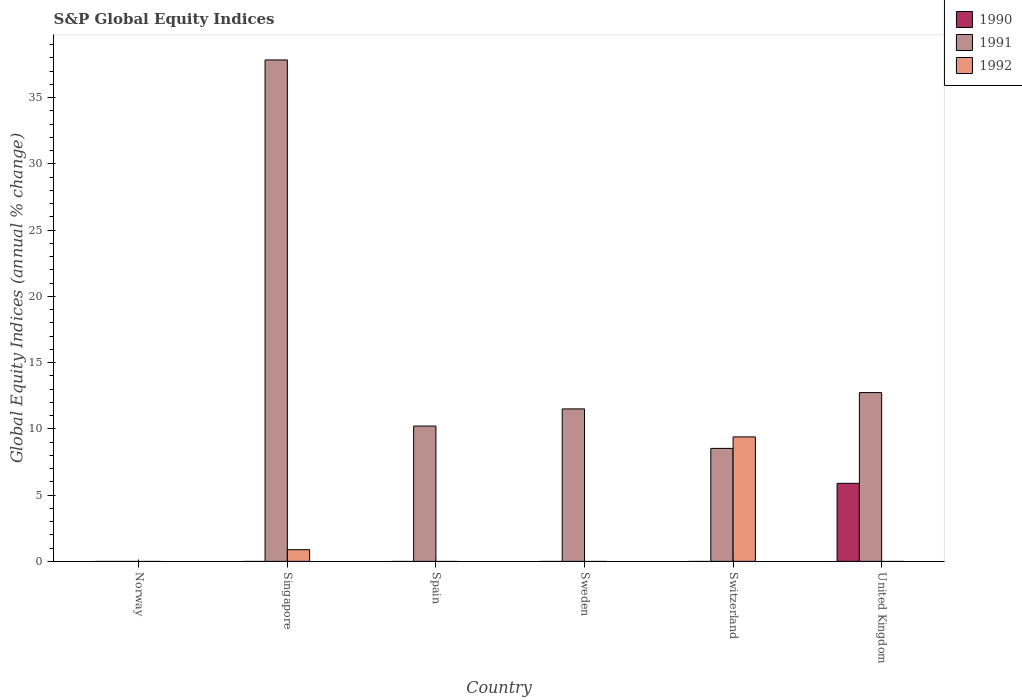Are the number of bars per tick equal to the number of legend labels?
Ensure brevity in your answer.  No. Are the number of bars on each tick of the X-axis equal?
Offer a terse response. No. How many bars are there on the 5th tick from the left?
Keep it short and to the point. 2. How many bars are there on the 3rd tick from the right?
Give a very brief answer. 1. What is the global equity indices in 1992 in Switzerland?
Keep it short and to the point. 9.4. Across all countries, what is the maximum global equity indices in 1991?
Your answer should be compact. 37.85. Across all countries, what is the minimum global equity indices in 1991?
Provide a succinct answer. 0. In which country was the global equity indices in 1992 maximum?
Provide a succinct answer. Switzerland. What is the total global equity indices in 1991 in the graph?
Ensure brevity in your answer.  80.84. What is the difference between the global equity indices in 1991 in Singapore and that in Spain?
Your answer should be compact. 27.64. What is the difference between the global equity indices in 1992 in Sweden and the global equity indices in 1991 in Singapore?
Give a very brief answer. -37.85. What is the average global equity indices in 1990 per country?
Provide a short and direct response. 0.98. What is the difference between the global equity indices of/in 1990 and global equity indices of/in 1991 in United Kingdom?
Provide a short and direct response. -6.85. In how many countries, is the global equity indices in 1991 greater than 17 %?
Provide a short and direct response. 1. What is the ratio of the global equity indices in 1991 in Sweden to that in United Kingdom?
Give a very brief answer. 0.9. What is the difference between the highest and the second highest global equity indices in 1991?
Ensure brevity in your answer.  -1.23. What is the difference between the highest and the lowest global equity indices in 1990?
Keep it short and to the point. 5.89. How many bars are there?
Provide a short and direct response. 8. Does the graph contain any zero values?
Keep it short and to the point. Yes. How many legend labels are there?
Make the answer very short. 3. How are the legend labels stacked?
Make the answer very short. Vertical. What is the title of the graph?
Ensure brevity in your answer.  S&P Global Equity Indices. Does "2008" appear as one of the legend labels in the graph?
Keep it short and to the point. No. What is the label or title of the Y-axis?
Provide a succinct answer. Global Equity Indices (annual % change). What is the Global Equity Indices (annual % change) in 1990 in Norway?
Offer a very short reply. 0. What is the Global Equity Indices (annual % change) in 1991 in Singapore?
Ensure brevity in your answer.  37.85. What is the Global Equity Indices (annual % change) in 1992 in Singapore?
Give a very brief answer. 0.88. What is the Global Equity Indices (annual % change) in 1990 in Spain?
Keep it short and to the point. 0. What is the Global Equity Indices (annual % change) of 1991 in Spain?
Your response must be concise. 10.21. What is the Global Equity Indices (annual % change) of 1990 in Sweden?
Make the answer very short. 0. What is the Global Equity Indices (annual % change) in 1991 in Sweden?
Your answer should be compact. 11.51. What is the Global Equity Indices (annual % change) in 1992 in Sweden?
Offer a very short reply. 0. What is the Global Equity Indices (annual % change) in 1991 in Switzerland?
Offer a very short reply. 8.53. What is the Global Equity Indices (annual % change) in 1992 in Switzerland?
Ensure brevity in your answer.  9.4. What is the Global Equity Indices (annual % change) of 1990 in United Kingdom?
Offer a very short reply. 5.89. What is the Global Equity Indices (annual % change) in 1991 in United Kingdom?
Offer a very short reply. 12.74. Across all countries, what is the maximum Global Equity Indices (annual % change) of 1990?
Keep it short and to the point. 5.89. Across all countries, what is the maximum Global Equity Indices (annual % change) of 1991?
Your answer should be very brief. 37.85. Across all countries, what is the maximum Global Equity Indices (annual % change) in 1992?
Provide a short and direct response. 9.4. Across all countries, what is the minimum Global Equity Indices (annual % change) in 1991?
Offer a terse response. 0. What is the total Global Equity Indices (annual % change) of 1990 in the graph?
Your response must be concise. 5.89. What is the total Global Equity Indices (annual % change) of 1991 in the graph?
Provide a short and direct response. 80.84. What is the total Global Equity Indices (annual % change) of 1992 in the graph?
Provide a short and direct response. 10.28. What is the difference between the Global Equity Indices (annual % change) of 1991 in Singapore and that in Spain?
Offer a very short reply. 27.64. What is the difference between the Global Equity Indices (annual % change) in 1991 in Singapore and that in Sweden?
Make the answer very short. 26.34. What is the difference between the Global Equity Indices (annual % change) of 1991 in Singapore and that in Switzerland?
Offer a very short reply. 29.32. What is the difference between the Global Equity Indices (annual % change) in 1992 in Singapore and that in Switzerland?
Ensure brevity in your answer.  -8.51. What is the difference between the Global Equity Indices (annual % change) of 1991 in Singapore and that in United Kingdom?
Offer a very short reply. 25.11. What is the difference between the Global Equity Indices (annual % change) of 1991 in Spain and that in Sweden?
Keep it short and to the point. -1.29. What is the difference between the Global Equity Indices (annual % change) of 1991 in Spain and that in Switzerland?
Your answer should be compact. 1.69. What is the difference between the Global Equity Indices (annual % change) of 1991 in Spain and that in United Kingdom?
Your answer should be compact. -2.53. What is the difference between the Global Equity Indices (annual % change) in 1991 in Sweden and that in Switzerland?
Ensure brevity in your answer.  2.98. What is the difference between the Global Equity Indices (annual % change) of 1991 in Sweden and that in United Kingdom?
Keep it short and to the point. -1.23. What is the difference between the Global Equity Indices (annual % change) of 1991 in Switzerland and that in United Kingdom?
Provide a short and direct response. -4.21. What is the difference between the Global Equity Indices (annual % change) of 1991 in Singapore and the Global Equity Indices (annual % change) of 1992 in Switzerland?
Your answer should be very brief. 28.46. What is the difference between the Global Equity Indices (annual % change) of 1991 in Spain and the Global Equity Indices (annual % change) of 1992 in Switzerland?
Your answer should be very brief. 0.82. What is the difference between the Global Equity Indices (annual % change) of 1991 in Sweden and the Global Equity Indices (annual % change) of 1992 in Switzerland?
Provide a short and direct response. 2.11. What is the average Global Equity Indices (annual % change) of 1990 per country?
Ensure brevity in your answer.  0.98. What is the average Global Equity Indices (annual % change) of 1991 per country?
Ensure brevity in your answer.  13.47. What is the average Global Equity Indices (annual % change) in 1992 per country?
Your answer should be very brief. 1.71. What is the difference between the Global Equity Indices (annual % change) of 1991 and Global Equity Indices (annual % change) of 1992 in Singapore?
Your response must be concise. 36.97. What is the difference between the Global Equity Indices (annual % change) of 1991 and Global Equity Indices (annual % change) of 1992 in Switzerland?
Keep it short and to the point. -0.87. What is the difference between the Global Equity Indices (annual % change) of 1990 and Global Equity Indices (annual % change) of 1991 in United Kingdom?
Provide a short and direct response. -6.85. What is the ratio of the Global Equity Indices (annual % change) of 1991 in Singapore to that in Spain?
Offer a very short reply. 3.71. What is the ratio of the Global Equity Indices (annual % change) in 1991 in Singapore to that in Sweden?
Offer a terse response. 3.29. What is the ratio of the Global Equity Indices (annual % change) of 1991 in Singapore to that in Switzerland?
Offer a very short reply. 4.44. What is the ratio of the Global Equity Indices (annual % change) of 1992 in Singapore to that in Switzerland?
Keep it short and to the point. 0.09. What is the ratio of the Global Equity Indices (annual % change) of 1991 in Singapore to that in United Kingdom?
Provide a succinct answer. 2.97. What is the ratio of the Global Equity Indices (annual % change) of 1991 in Spain to that in Sweden?
Provide a succinct answer. 0.89. What is the ratio of the Global Equity Indices (annual % change) in 1991 in Spain to that in Switzerland?
Offer a terse response. 1.2. What is the ratio of the Global Equity Indices (annual % change) of 1991 in Spain to that in United Kingdom?
Your response must be concise. 0.8. What is the ratio of the Global Equity Indices (annual % change) in 1991 in Sweden to that in Switzerland?
Provide a succinct answer. 1.35. What is the ratio of the Global Equity Indices (annual % change) in 1991 in Sweden to that in United Kingdom?
Offer a terse response. 0.9. What is the ratio of the Global Equity Indices (annual % change) in 1991 in Switzerland to that in United Kingdom?
Your answer should be compact. 0.67. What is the difference between the highest and the second highest Global Equity Indices (annual % change) of 1991?
Your answer should be compact. 25.11. What is the difference between the highest and the lowest Global Equity Indices (annual % change) in 1990?
Ensure brevity in your answer.  5.89. What is the difference between the highest and the lowest Global Equity Indices (annual % change) of 1991?
Give a very brief answer. 37.85. What is the difference between the highest and the lowest Global Equity Indices (annual % change) in 1992?
Make the answer very short. 9.4. 